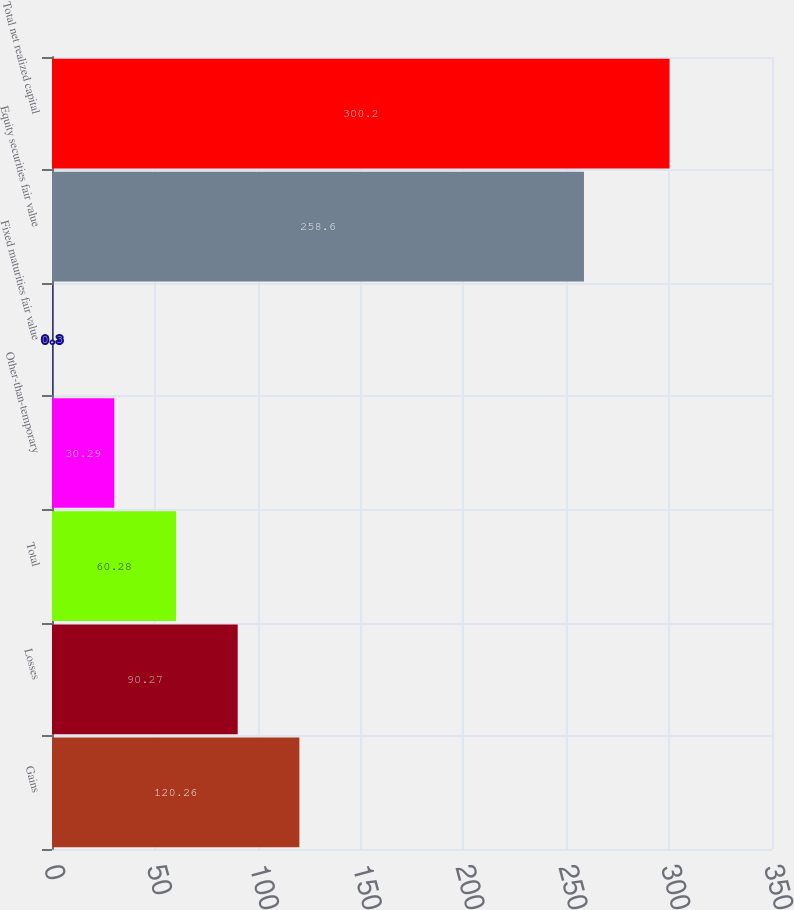Convert chart. <chart><loc_0><loc_0><loc_500><loc_500><bar_chart><fcel>Gains<fcel>Losses<fcel>Total<fcel>Other-than-temporary<fcel>Fixed maturities fair value<fcel>Equity securities fair value<fcel>Total net realized capital<nl><fcel>120.26<fcel>90.27<fcel>60.28<fcel>30.29<fcel>0.3<fcel>258.6<fcel>300.2<nl></chart> 